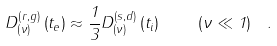Convert formula to latex. <formula><loc_0><loc_0><loc_500><loc_500>D _ { \left ( \nu \right ) } ^ { \left ( r , g \right ) } \left ( t _ { e } \right ) \approx \frac { 1 } { 3 } D _ { \left ( \nu \right ) } ^ { \left ( s , d \right ) } \left ( t _ { i } \right ) \quad \left ( \nu \ll 1 \right ) \ .</formula> 